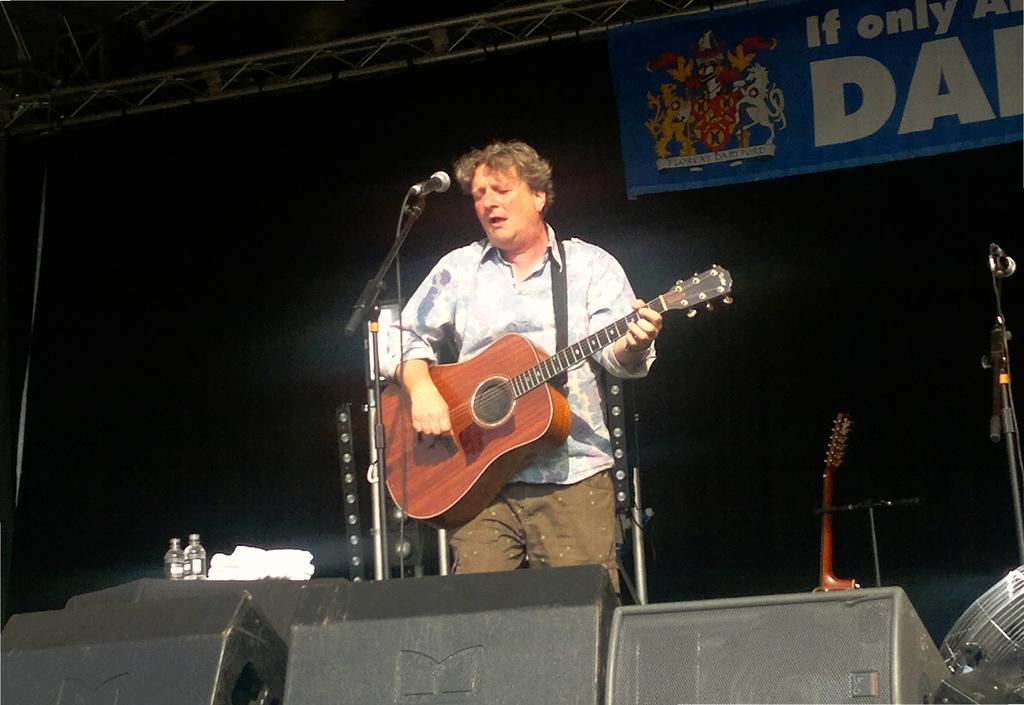In one or two sentences, can you explain what this image depicts? A man is standing and also playing the guitar. He is singing in the microphone. 